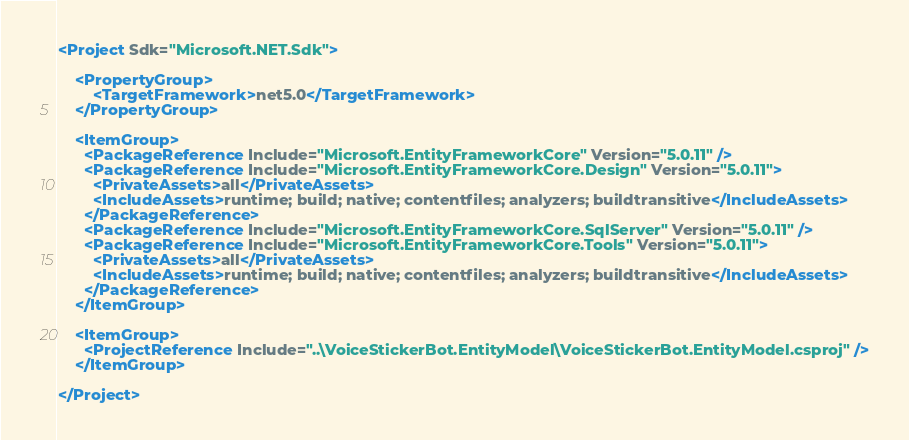Convert code to text. <code><loc_0><loc_0><loc_500><loc_500><_XML_><Project Sdk="Microsoft.NET.Sdk">

    <PropertyGroup>
        <TargetFramework>net5.0</TargetFramework>
    </PropertyGroup>

    <ItemGroup>
      <PackageReference Include="Microsoft.EntityFrameworkCore" Version="5.0.11" />
      <PackageReference Include="Microsoft.EntityFrameworkCore.Design" Version="5.0.11">
        <PrivateAssets>all</PrivateAssets>
        <IncludeAssets>runtime; build; native; contentfiles; analyzers; buildtransitive</IncludeAssets>
      </PackageReference>
      <PackageReference Include="Microsoft.EntityFrameworkCore.SqlServer" Version="5.0.11" />
      <PackageReference Include="Microsoft.EntityFrameworkCore.Tools" Version="5.0.11">
        <PrivateAssets>all</PrivateAssets>
        <IncludeAssets>runtime; build; native; contentfiles; analyzers; buildtransitive</IncludeAssets>
      </PackageReference>
    </ItemGroup>

    <ItemGroup>
      <ProjectReference Include="..\VoiceStickerBot.EntityModel\VoiceStickerBot.EntityModel.csproj" />
    </ItemGroup>

</Project>
</code> 